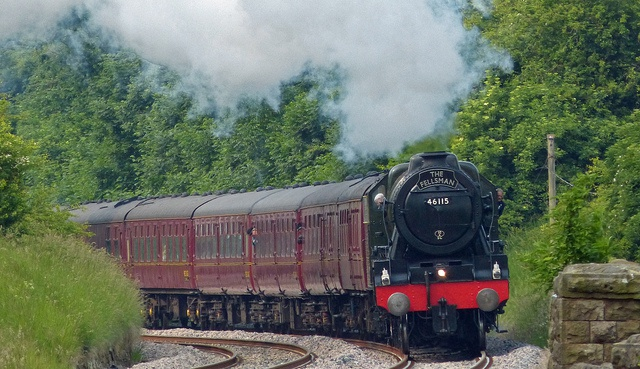Describe the objects in this image and their specific colors. I can see a train in darkgray, black, and gray tones in this image. 